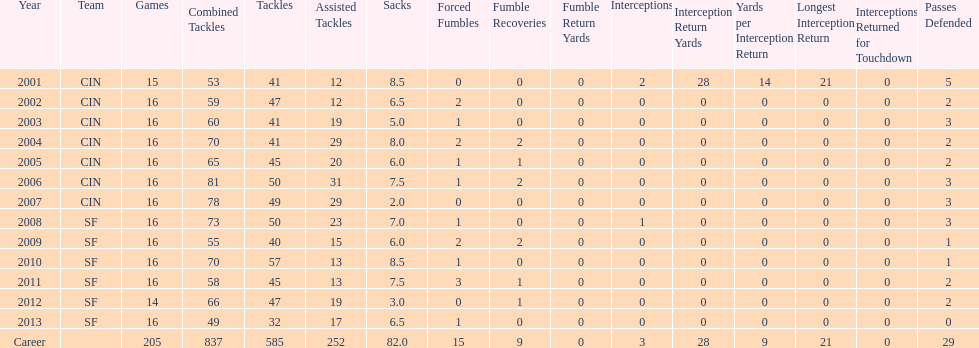How many seasons witnessed a total of 70 or more tackles combined? 5. 